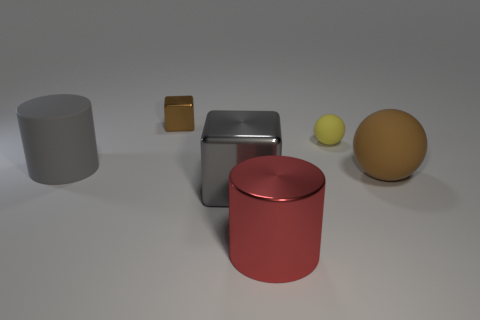What color is the tiny ball?
Make the answer very short. Yellow. There is a cylinder that is behind the red metallic cylinder; is its size the same as the brown object right of the red metallic cylinder?
Give a very brief answer. Yes. There is a thing that is both in front of the gray rubber cylinder and to the right of the large red metal cylinder; what is its size?
Your answer should be very brief. Large. What is the color of the other object that is the same shape as the big gray metal thing?
Your response must be concise. Brown. Is the number of gray objects to the left of the brown block greater than the number of brown things that are left of the large rubber cylinder?
Your answer should be very brief. Yes. What number of other objects are there of the same shape as the big red object?
Provide a short and direct response. 1. Are there any large red metal cylinders on the left side of the large rubber thing that is left of the small brown metal thing?
Ensure brevity in your answer.  No. What number of brown metallic blocks are there?
Ensure brevity in your answer.  1. Does the small sphere have the same color as the large object to the left of the gray shiny cube?
Keep it short and to the point. No. Are there more gray shiny cubes than gray things?
Provide a short and direct response. No. 